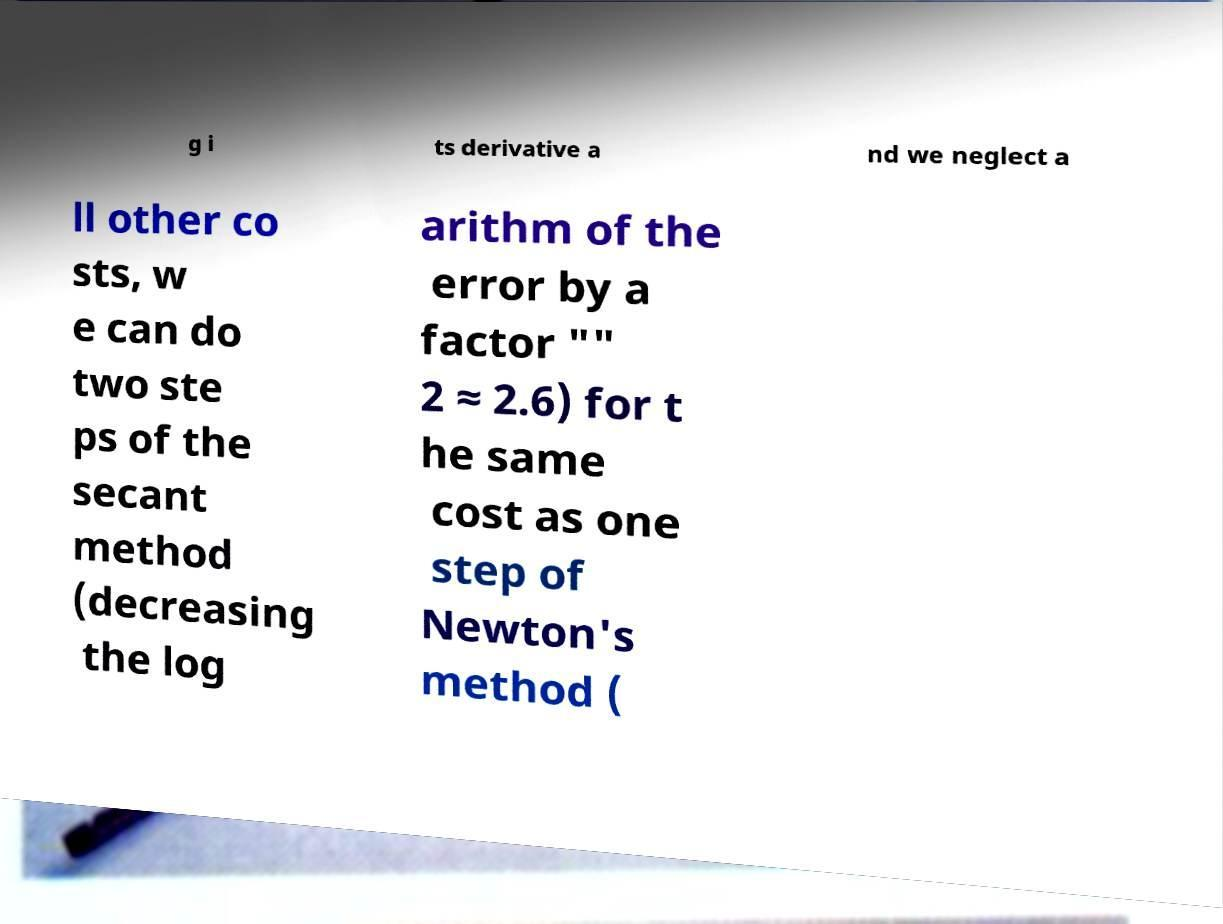I need the written content from this picture converted into text. Can you do that? g i ts derivative a nd we neglect a ll other co sts, w e can do two ste ps of the secant method (decreasing the log arithm of the error by a factor "" 2 ≈ 2.6) for t he same cost as one step of Newton's method ( 